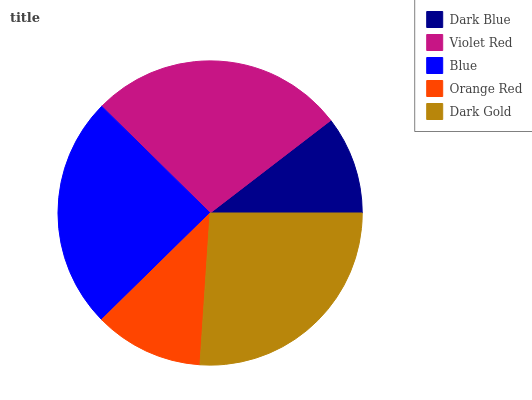Is Dark Blue the minimum?
Answer yes or no. Yes. Is Violet Red the maximum?
Answer yes or no. Yes. Is Blue the minimum?
Answer yes or no. No. Is Blue the maximum?
Answer yes or no. No. Is Violet Red greater than Blue?
Answer yes or no. Yes. Is Blue less than Violet Red?
Answer yes or no. Yes. Is Blue greater than Violet Red?
Answer yes or no. No. Is Violet Red less than Blue?
Answer yes or no. No. Is Blue the high median?
Answer yes or no. Yes. Is Blue the low median?
Answer yes or no. Yes. Is Dark Gold the high median?
Answer yes or no. No. Is Dark Gold the low median?
Answer yes or no. No. 